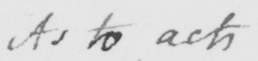Can you read and transcribe this handwriting? As to acts 